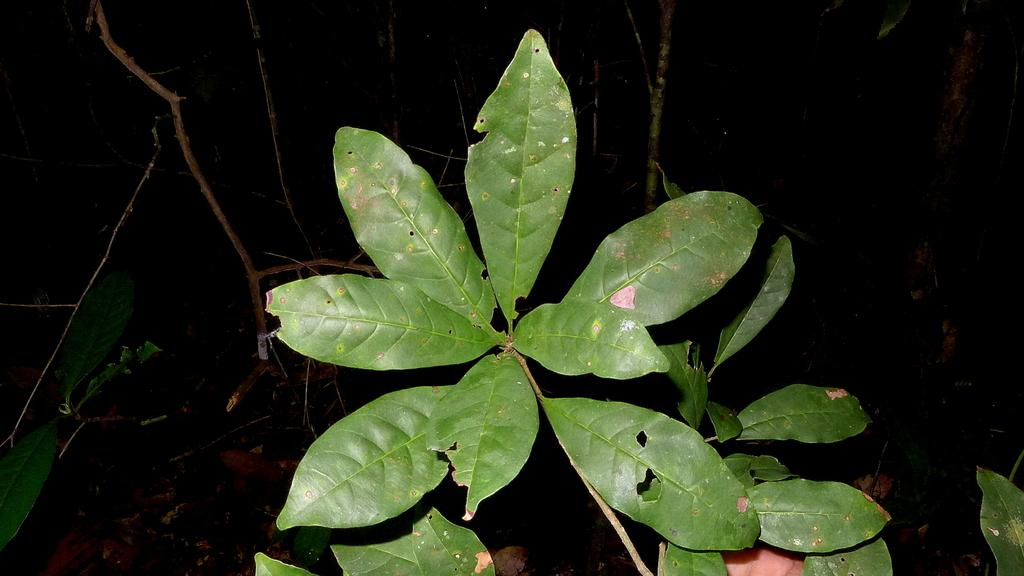What is the main subject in the center of the image? There is a plant in the center of the image. What can be seen in the background of the image? There are dry branches in the background of the image. How many boats are visible in the image? There are no boats present in the image. What type of school can be seen in the background of the image? There is no school present in the image; it only features a plant and dry branches. 